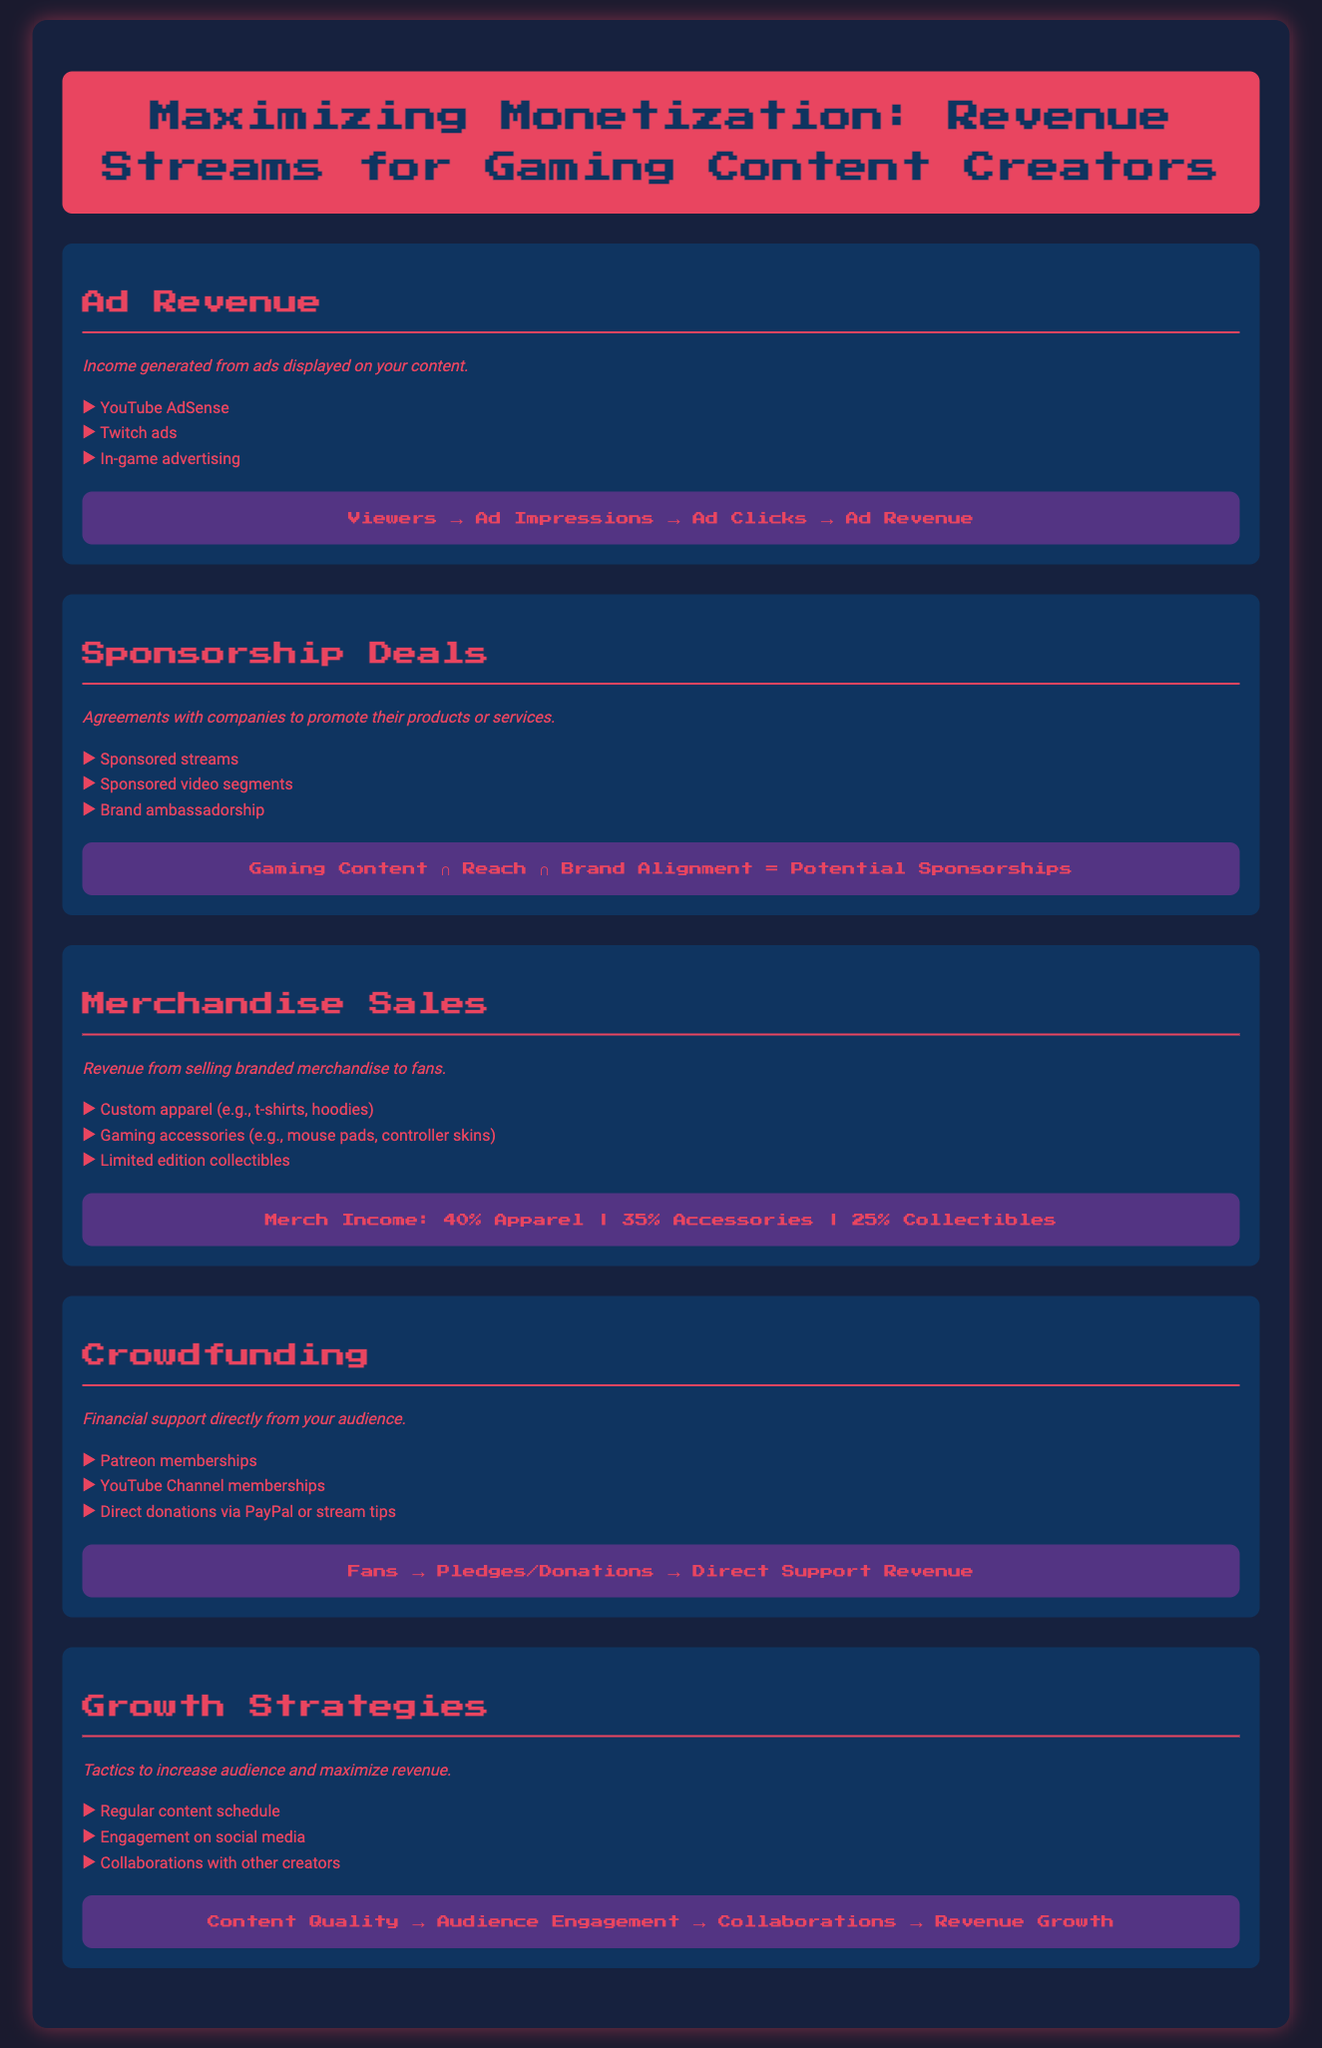What are the sources of ad revenue? The document lists specific sources of ad revenue, including YouTube AdSense, Twitch ads, and in-game advertising.
Answer: YouTube AdSense, Twitch ads, in-game advertising What is a key component for sponsorship deals? The document states that potential sponsorships are influenced by gaming content, reach, and brand alignment.
Answer: Gaming Content, Reach, Brand Alignment What percentage of merchandise sales comes from apparel? The infographic breaks down merchandise income by category and shows that 40% comes from apparel.
Answer: 40% What kind of support does crowdfunding involve? The crowdfunding section mentions financial support directly from the audience, which includes methods like Patreon and direct donations.
Answer: Financial support from audience What is one growth strategy mentioned in the document? The growth strategies section lists tactics such as regular content schedule, engagement on social media, and collaborations.
Answer: Regular content schedule 